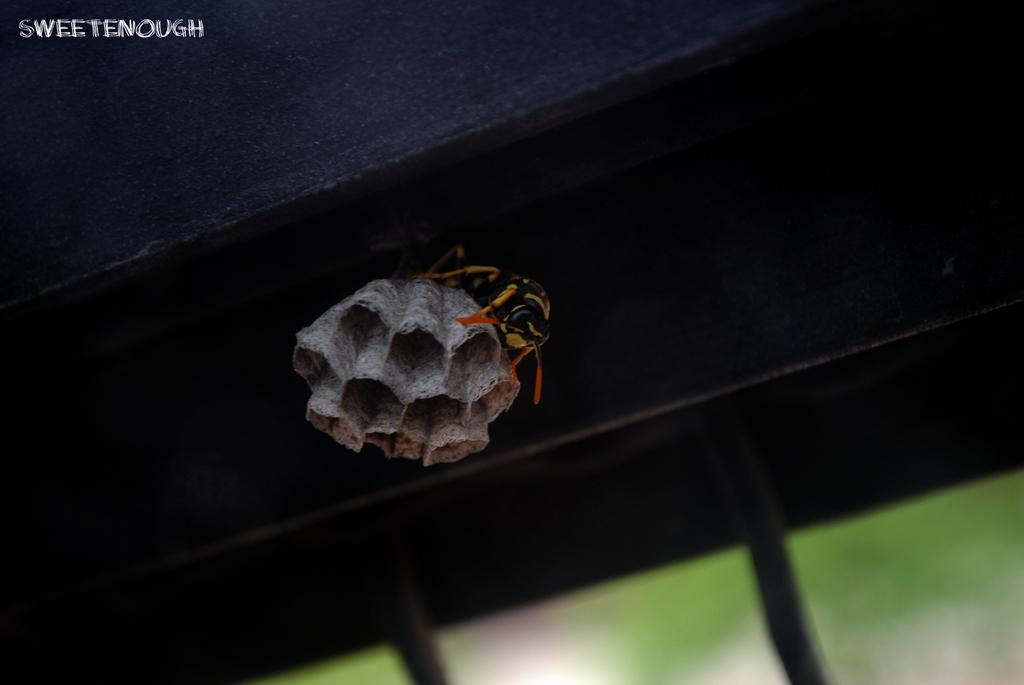What type of insect can be seen in the image? There is a bee in the image. What is present at the top of the image? There is a watermark at the top of the image. What type of glove is the government using to cause trouble in the image? There is no glove, government, or indication of trouble present in the image; it only features a bee and a watermark. 